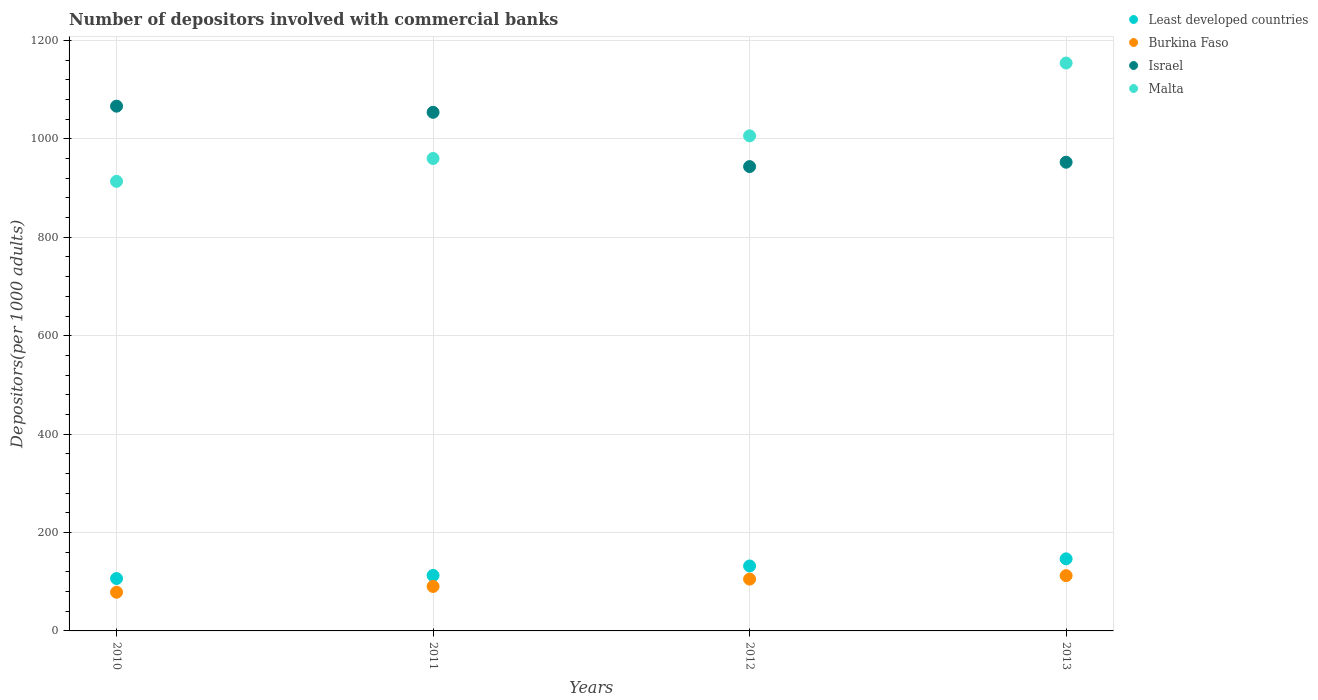What is the number of depositors involved with commercial banks in Burkina Faso in 2012?
Provide a succinct answer. 105.33. Across all years, what is the maximum number of depositors involved with commercial banks in Israel?
Make the answer very short. 1066.56. Across all years, what is the minimum number of depositors involved with commercial banks in Malta?
Offer a very short reply. 913.8. What is the total number of depositors involved with commercial banks in Burkina Faso in the graph?
Offer a terse response. 386.72. What is the difference between the number of depositors involved with commercial banks in Israel in 2010 and that in 2012?
Provide a short and direct response. 122.84. What is the difference between the number of depositors involved with commercial banks in Burkina Faso in 2011 and the number of depositors involved with commercial banks in Malta in 2012?
Your response must be concise. -915.79. What is the average number of depositors involved with commercial banks in Israel per year?
Provide a succinct answer. 1004.24. In the year 2011, what is the difference between the number of depositors involved with commercial banks in Least developed countries and number of depositors involved with commercial banks in Burkina Faso?
Ensure brevity in your answer.  22.37. In how many years, is the number of depositors involved with commercial banks in Israel greater than 1160?
Provide a succinct answer. 0. What is the ratio of the number of depositors involved with commercial banks in Burkina Faso in 2010 to that in 2011?
Offer a terse response. 0.87. Is the difference between the number of depositors involved with commercial banks in Least developed countries in 2010 and 2012 greater than the difference between the number of depositors involved with commercial banks in Burkina Faso in 2010 and 2012?
Offer a terse response. Yes. What is the difference between the highest and the second highest number of depositors involved with commercial banks in Least developed countries?
Provide a succinct answer. 14.52. What is the difference between the highest and the lowest number of depositors involved with commercial banks in Malta?
Make the answer very short. 240.42. Is the sum of the number of depositors involved with commercial banks in Malta in 2012 and 2013 greater than the maximum number of depositors involved with commercial banks in Least developed countries across all years?
Your answer should be compact. Yes. Is it the case that in every year, the sum of the number of depositors involved with commercial banks in Burkina Faso and number of depositors involved with commercial banks in Malta  is greater than the sum of number of depositors involved with commercial banks in Least developed countries and number of depositors involved with commercial banks in Israel?
Your answer should be compact. Yes. Does the number of depositors involved with commercial banks in Burkina Faso monotonically increase over the years?
Offer a terse response. Yes. Is the number of depositors involved with commercial banks in Malta strictly greater than the number of depositors involved with commercial banks in Israel over the years?
Your response must be concise. No. Is the number of depositors involved with commercial banks in Malta strictly less than the number of depositors involved with commercial banks in Burkina Faso over the years?
Give a very brief answer. No. How many dotlines are there?
Keep it short and to the point. 4. How many years are there in the graph?
Your answer should be compact. 4. Are the values on the major ticks of Y-axis written in scientific E-notation?
Make the answer very short. No. Where does the legend appear in the graph?
Your response must be concise. Top right. How are the legend labels stacked?
Make the answer very short. Vertical. What is the title of the graph?
Provide a short and direct response. Number of depositors involved with commercial banks. What is the label or title of the Y-axis?
Ensure brevity in your answer.  Depositors(per 1000 adults). What is the Depositors(per 1000 adults) in Least developed countries in 2010?
Your answer should be very brief. 106.48. What is the Depositors(per 1000 adults) of Burkina Faso in 2010?
Provide a succinct answer. 78.64. What is the Depositors(per 1000 adults) of Israel in 2010?
Keep it short and to the point. 1066.56. What is the Depositors(per 1000 adults) in Malta in 2010?
Provide a succinct answer. 913.8. What is the Depositors(per 1000 adults) of Least developed countries in 2011?
Make the answer very short. 112.8. What is the Depositors(per 1000 adults) of Burkina Faso in 2011?
Your response must be concise. 90.43. What is the Depositors(per 1000 adults) in Israel in 2011?
Your answer should be compact. 1054.06. What is the Depositors(per 1000 adults) in Malta in 2011?
Provide a succinct answer. 960.23. What is the Depositors(per 1000 adults) in Least developed countries in 2012?
Your response must be concise. 131.99. What is the Depositors(per 1000 adults) in Burkina Faso in 2012?
Provide a short and direct response. 105.33. What is the Depositors(per 1000 adults) in Israel in 2012?
Ensure brevity in your answer.  943.72. What is the Depositors(per 1000 adults) in Malta in 2012?
Provide a succinct answer. 1006.22. What is the Depositors(per 1000 adults) in Least developed countries in 2013?
Provide a succinct answer. 146.51. What is the Depositors(per 1000 adults) in Burkina Faso in 2013?
Provide a succinct answer. 112.33. What is the Depositors(per 1000 adults) in Israel in 2013?
Offer a terse response. 952.62. What is the Depositors(per 1000 adults) of Malta in 2013?
Offer a terse response. 1154.22. Across all years, what is the maximum Depositors(per 1000 adults) in Least developed countries?
Your response must be concise. 146.51. Across all years, what is the maximum Depositors(per 1000 adults) of Burkina Faso?
Your answer should be compact. 112.33. Across all years, what is the maximum Depositors(per 1000 adults) of Israel?
Offer a terse response. 1066.56. Across all years, what is the maximum Depositors(per 1000 adults) in Malta?
Offer a terse response. 1154.22. Across all years, what is the minimum Depositors(per 1000 adults) of Least developed countries?
Your response must be concise. 106.48. Across all years, what is the minimum Depositors(per 1000 adults) of Burkina Faso?
Your answer should be very brief. 78.64. Across all years, what is the minimum Depositors(per 1000 adults) of Israel?
Your answer should be compact. 943.72. Across all years, what is the minimum Depositors(per 1000 adults) in Malta?
Offer a terse response. 913.8. What is the total Depositors(per 1000 adults) in Least developed countries in the graph?
Keep it short and to the point. 497.78. What is the total Depositors(per 1000 adults) in Burkina Faso in the graph?
Provide a short and direct response. 386.72. What is the total Depositors(per 1000 adults) of Israel in the graph?
Your answer should be compact. 4016.96. What is the total Depositors(per 1000 adults) in Malta in the graph?
Your answer should be compact. 4034.47. What is the difference between the Depositors(per 1000 adults) in Least developed countries in 2010 and that in 2011?
Your answer should be very brief. -6.32. What is the difference between the Depositors(per 1000 adults) of Burkina Faso in 2010 and that in 2011?
Keep it short and to the point. -11.79. What is the difference between the Depositors(per 1000 adults) of Israel in 2010 and that in 2011?
Your response must be concise. 12.5. What is the difference between the Depositors(per 1000 adults) of Malta in 2010 and that in 2011?
Provide a succinct answer. -46.43. What is the difference between the Depositors(per 1000 adults) in Least developed countries in 2010 and that in 2012?
Make the answer very short. -25.51. What is the difference between the Depositors(per 1000 adults) of Burkina Faso in 2010 and that in 2012?
Keep it short and to the point. -26.69. What is the difference between the Depositors(per 1000 adults) of Israel in 2010 and that in 2012?
Provide a short and direct response. 122.84. What is the difference between the Depositors(per 1000 adults) of Malta in 2010 and that in 2012?
Your answer should be very brief. -92.42. What is the difference between the Depositors(per 1000 adults) in Least developed countries in 2010 and that in 2013?
Offer a very short reply. -40.03. What is the difference between the Depositors(per 1000 adults) of Burkina Faso in 2010 and that in 2013?
Ensure brevity in your answer.  -33.69. What is the difference between the Depositors(per 1000 adults) of Israel in 2010 and that in 2013?
Make the answer very short. 113.94. What is the difference between the Depositors(per 1000 adults) in Malta in 2010 and that in 2013?
Make the answer very short. -240.42. What is the difference between the Depositors(per 1000 adults) in Least developed countries in 2011 and that in 2012?
Provide a succinct answer. -19.19. What is the difference between the Depositors(per 1000 adults) of Burkina Faso in 2011 and that in 2012?
Your answer should be compact. -14.9. What is the difference between the Depositors(per 1000 adults) of Israel in 2011 and that in 2012?
Give a very brief answer. 110.33. What is the difference between the Depositors(per 1000 adults) of Malta in 2011 and that in 2012?
Ensure brevity in your answer.  -45.99. What is the difference between the Depositors(per 1000 adults) in Least developed countries in 2011 and that in 2013?
Offer a terse response. -33.71. What is the difference between the Depositors(per 1000 adults) of Burkina Faso in 2011 and that in 2013?
Make the answer very short. -21.9. What is the difference between the Depositors(per 1000 adults) of Israel in 2011 and that in 2013?
Provide a short and direct response. 101.44. What is the difference between the Depositors(per 1000 adults) in Malta in 2011 and that in 2013?
Make the answer very short. -193.99. What is the difference between the Depositors(per 1000 adults) of Least developed countries in 2012 and that in 2013?
Offer a very short reply. -14.53. What is the difference between the Depositors(per 1000 adults) in Burkina Faso in 2012 and that in 2013?
Your answer should be compact. -7. What is the difference between the Depositors(per 1000 adults) of Israel in 2012 and that in 2013?
Provide a succinct answer. -8.9. What is the difference between the Depositors(per 1000 adults) of Malta in 2012 and that in 2013?
Make the answer very short. -148. What is the difference between the Depositors(per 1000 adults) in Least developed countries in 2010 and the Depositors(per 1000 adults) in Burkina Faso in 2011?
Make the answer very short. 16.05. What is the difference between the Depositors(per 1000 adults) in Least developed countries in 2010 and the Depositors(per 1000 adults) in Israel in 2011?
Ensure brevity in your answer.  -947.58. What is the difference between the Depositors(per 1000 adults) in Least developed countries in 2010 and the Depositors(per 1000 adults) in Malta in 2011?
Provide a short and direct response. -853.75. What is the difference between the Depositors(per 1000 adults) in Burkina Faso in 2010 and the Depositors(per 1000 adults) in Israel in 2011?
Make the answer very short. -975.42. What is the difference between the Depositors(per 1000 adults) in Burkina Faso in 2010 and the Depositors(per 1000 adults) in Malta in 2011?
Ensure brevity in your answer.  -881.59. What is the difference between the Depositors(per 1000 adults) in Israel in 2010 and the Depositors(per 1000 adults) in Malta in 2011?
Make the answer very short. 106.33. What is the difference between the Depositors(per 1000 adults) of Least developed countries in 2010 and the Depositors(per 1000 adults) of Burkina Faso in 2012?
Make the answer very short. 1.15. What is the difference between the Depositors(per 1000 adults) of Least developed countries in 2010 and the Depositors(per 1000 adults) of Israel in 2012?
Offer a very short reply. -837.24. What is the difference between the Depositors(per 1000 adults) in Least developed countries in 2010 and the Depositors(per 1000 adults) in Malta in 2012?
Your answer should be compact. -899.74. What is the difference between the Depositors(per 1000 adults) in Burkina Faso in 2010 and the Depositors(per 1000 adults) in Israel in 2012?
Your answer should be compact. -865.09. What is the difference between the Depositors(per 1000 adults) in Burkina Faso in 2010 and the Depositors(per 1000 adults) in Malta in 2012?
Your answer should be very brief. -927.58. What is the difference between the Depositors(per 1000 adults) of Israel in 2010 and the Depositors(per 1000 adults) of Malta in 2012?
Your answer should be compact. 60.34. What is the difference between the Depositors(per 1000 adults) of Least developed countries in 2010 and the Depositors(per 1000 adults) of Burkina Faso in 2013?
Offer a very short reply. -5.85. What is the difference between the Depositors(per 1000 adults) in Least developed countries in 2010 and the Depositors(per 1000 adults) in Israel in 2013?
Give a very brief answer. -846.14. What is the difference between the Depositors(per 1000 adults) of Least developed countries in 2010 and the Depositors(per 1000 adults) of Malta in 2013?
Your response must be concise. -1047.74. What is the difference between the Depositors(per 1000 adults) of Burkina Faso in 2010 and the Depositors(per 1000 adults) of Israel in 2013?
Offer a very short reply. -873.98. What is the difference between the Depositors(per 1000 adults) of Burkina Faso in 2010 and the Depositors(per 1000 adults) of Malta in 2013?
Offer a very short reply. -1075.58. What is the difference between the Depositors(per 1000 adults) in Israel in 2010 and the Depositors(per 1000 adults) in Malta in 2013?
Your answer should be very brief. -87.66. What is the difference between the Depositors(per 1000 adults) of Least developed countries in 2011 and the Depositors(per 1000 adults) of Burkina Faso in 2012?
Keep it short and to the point. 7.47. What is the difference between the Depositors(per 1000 adults) in Least developed countries in 2011 and the Depositors(per 1000 adults) in Israel in 2012?
Provide a succinct answer. -830.92. What is the difference between the Depositors(per 1000 adults) of Least developed countries in 2011 and the Depositors(per 1000 adults) of Malta in 2012?
Offer a terse response. -893.42. What is the difference between the Depositors(per 1000 adults) of Burkina Faso in 2011 and the Depositors(per 1000 adults) of Israel in 2012?
Provide a short and direct response. -853.3. What is the difference between the Depositors(per 1000 adults) in Burkina Faso in 2011 and the Depositors(per 1000 adults) in Malta in 2012?
Your response must be concise. -915.79. What is the difference between the Depositors(per 1000 adults) in Israel in 2011 and the Depositors(per 1000 adults) in Malta in 2012?
Make the answer very short. 47.84. What is the difference between the Depositors(per 1000 adults) in Least developed countries in 2011 and the Depositors(per 1000 adults) in Burkina Faso in 2013?
Provide a short and direct response. 0.47. What is the difference between the Depositors(per 1000 adults) in Least developed countries in 2011 and the Depositors(per 1000 adults) in Israel in 2013?
Your response must be concise. -839.82. What is the difference between the Depositors(per 1000 adults) of Least developed countries in 2011 and the Depositors(per 1000 adults) of Malta in 2013?
Your answer should be very brief. -1041.42. What is the difference between the Depositors(per 1000 adults) of Burkina Faso in 2011 and the Depositors(per 1000 adults) of Israel in 2013?
Give a very brief answer. -862.19. What is the difference between the Depositors(per 1000 adults) in Burkina Faso in 2011 and the Depositors(per 1000 adults) in Malta in 2013?
Offer a terse response. -1063.79. What is the difference between the Depositors(per 1000 adults) in Israel in 2011 and the Depositors(per 1000 adults) in Malta in 2013?
Offer a very short reply. -100.16. What is the difference between the Depositors(per 1000 adults) in Least developed countries in 2012 and the Depositors(per 1000 adults) in Burkina Faso in 2013?
Provide a succinct answer. 19.66. What is the difference between the Depositors(per 1000 adults) of Least developed countries in 2012 and the Depositors(per 1000 adults) of Israel in 2013?
Keep it short and to the point. -820.63. What is the difference between the Depositors(per 1000 adults) of Least developed countries in 2012 and the Depositors(per 1000 adults) of Malta in 2013?
Your answer should be very brief. -1022.23. What is the difference between the Depositors(per 1000 adults) of Burkina Faso in 2012 and the Depositors(per 1000 adults) of Israel in 2013?
Your response must be concise. -847.29. What is the difference between the Depositors(per 1000 adults) of Burkina Faso in 2012 and the Depositors(per 1000 adults) of Malta in 2013?
Your response must be concise. -1048.89. What is the difference between the Depositors(per 1000 adults) in Israel in 2012 and the Depositors(per 1000 adults) in Malta in 2013?
Offer a terse response. -210.49. What is the average Depositors(per 1000 adults) of Least developed countries per year?
Ensure brevity in your answer.  124.45. What is the average Depositors(per 1000 adults) of Burkina Faso per year?
Offer a very short reply. 96.68. What is the average Depositors(per 1000 adults) of Israel per year?
Provide a succinct answer. 1004.24. What is the average Depositors(per 1000 adults) in Malta per year?
Keep it short and to the point. 1008.62. In the year 2010, what is the difference between the Depositors(per 1000 adults) in Least developed countries and Depositors(per 1000 adults) in Burkina Faso?
Your response must be concise. 27.84. In the year 2010, what is the difference between the Depositors(per 1000 adults) of Least developed countries and Depositors(per 1000 adults) of Israel?
Your answer should be compact. -960.08. In the year 2010, what is the difference between the Depositors(per 1000 adults) of Least developed countries and Depositors(per 1000 adults) of Malta?
Give a very brief answer. -807.32. In the year 2010, what is the difference between the Depositors(per 1000 adults) in Burkina Faso and Depositors(per 1000 adults) in Israel?
Your answer should be very brief. -987.92. In the year 2010, what is the difference between the Depositors(per 1000 adults) in Burkina Faso and Depositors(per 1000 adults) in Malta?
Provide a succinct answer. -835.16. In the year 2010, what is the difference between the Depositors(per 1000 adults) in Israel and Depositors(per 1000 adults) in Malta?
Ensure brevity in your answer.  152.76. In the year 2011, what is the difference between the Depositors(per 1000 adults) of Least developed countries and Depositors(per 1000 adults) of Burkina Faso?
Keep it short and to the point. 22.37. In the year 2011, what is the difference between the Depositors(per 1000 adults) in Least developed countries and Depositors(per 1000 adults) in Israel?
Give a very brief answer. -941.26. In the year 2011, what is the difference between the Depositors(per 1000 adults) in Least developed countries and Depositors(per 1000 adults) in Malta?
Offer a terse response. -847.43. In the year 2011, what is the difference between the Depositors(per 1000 adults) in Burkina Faso and Depositors(per 1000 adults) in Israel?
Keep it short and to the point. -963.63. In the year 2011, what is the difference between the Depositors(per 1000 adults) in Burkina Faso and Depositors(per 1000 adults) in Malta?
Your answer should be very brief. -869.8. In the year 2011, what is the difference between the Depositors(per 1000 adults) of Israel and Depositors(per 1000 adults) of Malta?
Offer a terse response. 93.83. In the year 2012, what is the difference between the Depositors(per 1000 adults) in Least developed countries and Depositors(per 1000 adults) in Burkina Faso?
Your response must be concise. 26.66. In the year 2012, what is the difference between the Depositors(per 1000 adults) of Least developed countries and Depositors(per 1000 adults) of Israel?
Offer a terse response. -811.74. In the year 2012, what is the difference between the Depositors(per 1000 adults) of Least developed countries and Depositors(per 1000 adults) of Malta?
Provide a succinct answer. -874.23. In the year 2012, what is the difference between the Depositors(per 1000 adults) of Burkina Faso and Depositors(per 1000 adults) of Israel?
Give a very brief answer. -838.39. In the year 2012, what is the difference between the Depositors(per 1000 adults) in Burkina Faso and Depositors(per 1000 adults) in Malta?
Offer a very short reply. -900.89. In the year 2012, what is the difference between the Depositors(per 1000 adults) in Israel and Depositors(per 1000 adults) in Malta?
Make the answer very short. -62.5. In the year 2013, what is the difference between the Depositors(per 1000 adults) of Least developed countries and Depositors(per 1000 adults) of Burkina Faso?
Ensure brevity in your answer.  34.19. In the year 2013, what is the difference between the Depositors(per 1000 adults) in Least developed countries and Depositors(per 1000 adults) in Israel?
Provide a succinct answer. -806.11. In the year 2013, what is the difference between the Depositors(per 1000 adults) of Least developed countries and Depositors(per 1000 adults) of Malta?
Your response must be concise. -1007.7. In the year 2013, what is the difference between the Depositors(per 1000 adults) in Burkina Faso and Depositors(per 1000 adults) in Israel?
Give a very brief answer. -840.29. In the year 2013, what is the difference between the Depositors(per 1000 adults) of Burkina Faso and Depositors(per 1000 adults) of Malta?
Provide a short and direct response. -1041.89. In the year 2013, what is the difference between the Depositors(per 1000 adults) in Israel and Depositors(per 1000 adults) in Malta?
Provide a succinct answer. -201.6. What is the ratio of the Depositors(per 1000 adults) of Least developed countries in 2010 to that in 2011?
Your response must be concise. 0.94. What is the ratio of the Depositors(per 1000 adults) in Burkina Faso in 2010 to that in 2011?
Offer a very short reply. 0.87. What is the ratio of the Depositors(per 1000 adults) of Israel in 2010 to that in 2011?
Give a very brief answer. 1.01. What is the ratio of the Depositors(per 1000 adults) in Malta in 2010 to that in 2011?
Offer a very short reply. 0.95. What is the ratio of the Depositors(per 1000 adults) in Least developed countries in 2010 to that in 2012?
Ensure brevity in your answer.  0.81. What is the ratio of the Depositors(per 1000 adults) of Burkina Faso in 2010 to that in 2012?
Give a very brief answer. 0.75. What is the ratio of the Depositors(per 1000 adults) in Israel in 2010 to that in 2012?
Give a very brief answer. 1.13. What is the ratio of the Depositors(per 1000 adults) in Malta in 2010 to that in 2012?
Your answer should be compact. 0.91. What is the ratio of the Depositors(per 1000 adults) of Least developed countries in 2010 to that in 2013?
Give a very brief answer. 0.73. What is the ratio of the Depositors(per 1000 adults) in Burkina Faso in 2010 to that in 2013?
Offer a terse response. 0.7. What is the ratio of the Depositors(per 1000 adults) of Israel in 2010 to that in 2013?
Your response must be concise. 1.12. What is the ratio of the Depositors(per 1000 adults) of Malta in 2010 to that in 2013?
Give a very brief answer. 0.79. What is the ratio of the Depositors(per 1000 adults) in Least developed countries in 2011 to that in 2012?
Provide a short and direct response. 0.85. What is the ratio of the Depositors(per 1000 adults) in Burkina Faso in 2011 to that in 2012?
Offer a very short reply. 0.86. What is the ratio of the Depositors(per 1000 adults) of Israel in 2011 to that in 2012?
Offer a very short reply. 1.12. What is the ratio of the Depositors(per 1000 adults) of Malta in 2011 to that in 2012?
Your answer should be compact. 0.95. What is the ratio of the Depositors(per 1000 adults) of Least developed countries in 2011 to that in 2013?
Your answer should be compact. 0.77. What is the ratio of the Depositors(per 1000 adults) in Burkina Faso in 2011 to that in 2013?
Keep it short and to the point. 0.81. What is the ratio of the Depositors(per 1000 adults) of Israel in 2011 to that in 2013?
Provide a short and direct response. 1.11. What is the ratio of the Depositors(per 1000 adults) in Malta in 2011 to that in 2013?
Your answer should be compact. 0.83. What is the ratio of the Depositors(per 1000 adults) in Least developed countries in 2012 to that in 2013?
Ensure brevity in your answer.  0.9. What is the ratio of the Depositors(per 1000 adults) of Burkina Faso in 2012 to that in 2013?
Give a very brief answer. 0.94. What is the ratio of the Depositors(per 1000 adults) in Malta in 2012 to that in 2013?
Your response must be concise. 0.87. What is the difference between the highest and the second highest Depositors(per 1000 adults) in Least developed countries?
Offer a very short reply. 14.53. What is the difference between the highest and the second highest Depositors(per 1000 adults) of Burkina Faso?
Offer a very short reply. 7. What is the difference between the highest and the second highest Depositors(per 1000 adults) in Israel?
Keep it short and to the point. 12.5. What is the difference between the highest and the second highest Depositors(per 1000 adults) of Malta?
Provide a short and direct response. 148. What is the difference between the highest and the lowest Depositors(per 1000 adults) in Least developed countries?
Your answer should be very brief. 40.03. What is the difference between the highest and the lowest Depositors(per 1000 adults) of Burkina Faso?
Provide a short and direct response. 33.69. What is the difference between the highest and the lowest Depositors(per 1000 adults) of Israel?
Keep it short and to the point. 122.84. What is the difference between the highest and the lowest Depositors(per 1000 adults) of Malta?
Your answer should be very brief. 240.42. 